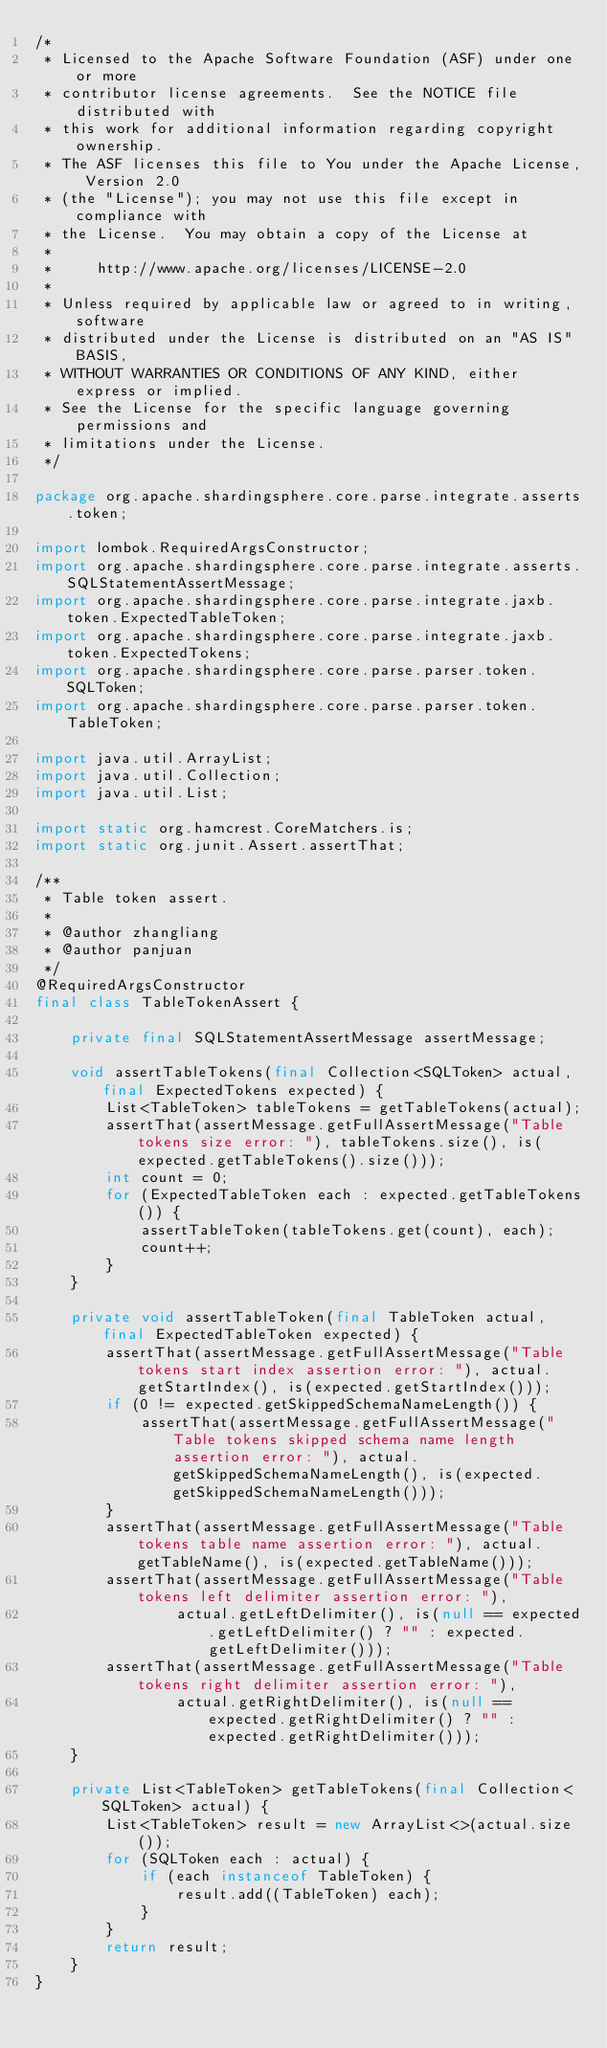Convert code to text. <code><loc_0><loc_0><loc_500><loc_500><_Java_>/*
 * Licensed to the Apache Software Foundation (ASF) under one or more
 * contributor license agreements.  See the NOTICE file distributed with
 * this work for additional information regarding copyright ownership.
 * The ASF licenses this file to You under the Apache License, Version 2.0
 * (the "License"); you may not use this file except in compliance with
 * the License.  You may obtain a copy of the License at
 *
 *     http://www.apache.org/licenses/LICENSE-2.0
 *
 * Unless required by applicable law or agreed to in writing, software
 * distributed under the License is distributed on an "AS IS" BASIS,
 * WITHOUT WARRANTIES OR CONDITIONS OF ANY KIND, either express or implied.
 * See the License for the specific language governing permissions and
 * limitations under the License.
 */

package org.apache.shardingsphere.core.parse.integrate.asserts.token;

import lombok.RequiredArgsConstructor;
import org.apache.shardingsphere.core.parse.integrate.asserts.SQLStatementAssertMessage;
import org.apache.shardingsphere.core.parse.integrate.jaxb.token.ExpectedTableToken;
import org.apache.shardingsphere.core.parse.integrate.jaxb.token.ExpectedTokens;
import org.apache.shardingsphere.core.parse.parser.token.SQLToken;
import org.apache.shardingsphere.core.parse.parser.token.TableToken;

import java.util.ArrayList;
import java.util.Collection;
import java.util.List;

import static org.hamcrest.CoreMatchers.is;
import static org.junit.Assert.assertThat;

/**
 * Table token assert.
 *
 * @author zhangliang
 * @author panjuan
 */
@RequiredArgsConstructor
final class TableTokenAssert {
    
    private final SQLStatementAssertMessage assertMessage;
    
    void assertTableTokens(final Collection<SQLToken> actual, final ExpectedTokens expected) {
        List<TableToken> tableTokens = getTableTokens(actual);
        assertThat(assertMessage.getFullAssertMessage("Table tokens size error: "), tableTokens.size(), is(expected.getTableTokens().size()));
        int count = 0;
        for (ExpectedTableToken each : expected.getTableTokens()) {
            assertTableToken(tableTokens.get(count), each);
            count++;
        }
    }
    
    private void assertTableToken(final TableToken actual, final ExpectedTableToken expected) {
        assertThat(assertMessage.getFullAssertMessage("Table tokens start index assertion error: "), actual.getStartIndex(), is(expected.getStartIndex()));
        if (0 != expected.getSkippedSchemaNameLength()) {
            assertThat(assertMessage.getFullAssertMessage("Table tokens skipped schema name length assertion error: "), actual.getSkippedSchemaNameLength(), is(expected.getSkippedSchemaNameLength()));
        }
        assertThat(assertMessage.getFullAssertMessage("Table tokens table name assertion error: "), actual.getTableName(), is(expected.getTableName()));
        assertThat(assertMessage.getFullAssertMessage("Table tokens left delimiter assertion error: "), 
                actual.getLeftDelimiter(), is(null == expected.getLeftDelimiter() ? "" : expected.getLeftDelimiter()));
        assertThat(assertMessage.getFullAssertMessage("Table tokens right delimiter assertion error: "), 
                actual.getRightDelimiter(), is(null == expected.getRightDelimiter() ? "" : expected.getRightDelimiter()));
    }
    
    private List<TableToken> getTableTokens(final Collection<SQLToken> actual) {
        List<TableToken> result = new ArrayList<>(actual.size());
        for (SQLToken each : actual) {
            if (each instanceof TableToken) {
                result.add((TableToken) each);
            }
        }
        return result;
    }
}
</code> 